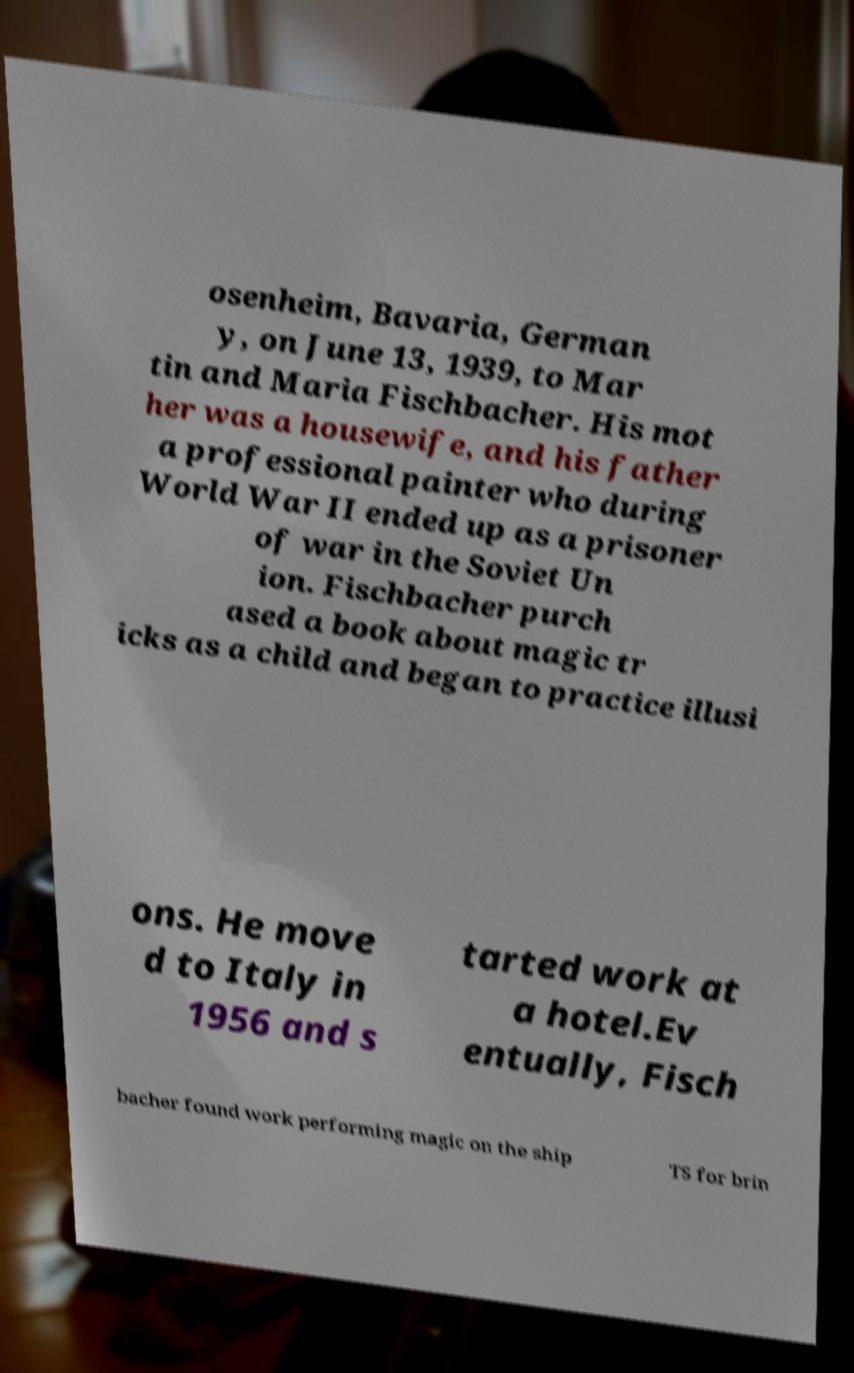Can you read and provide the text displayed in the image?This photo seems to have some interesting text. Can you extract and type it out for me? osenheim, Bavaria, German y, on June 13, 1939, to Mar tin and Maria Fischbacher. His mot her was a housewife, and his father a professional painter who during World War II ended up as a prisoner of war in the Soviet Un ion. Fischbacher purch ased a book about magic tr icks as a child and began to practice illusi ons. He move d to Italy in 1956 and s tarted work at a hotel.Ev entually, Fisch bacher found work performing magic on the ship TS for brin 